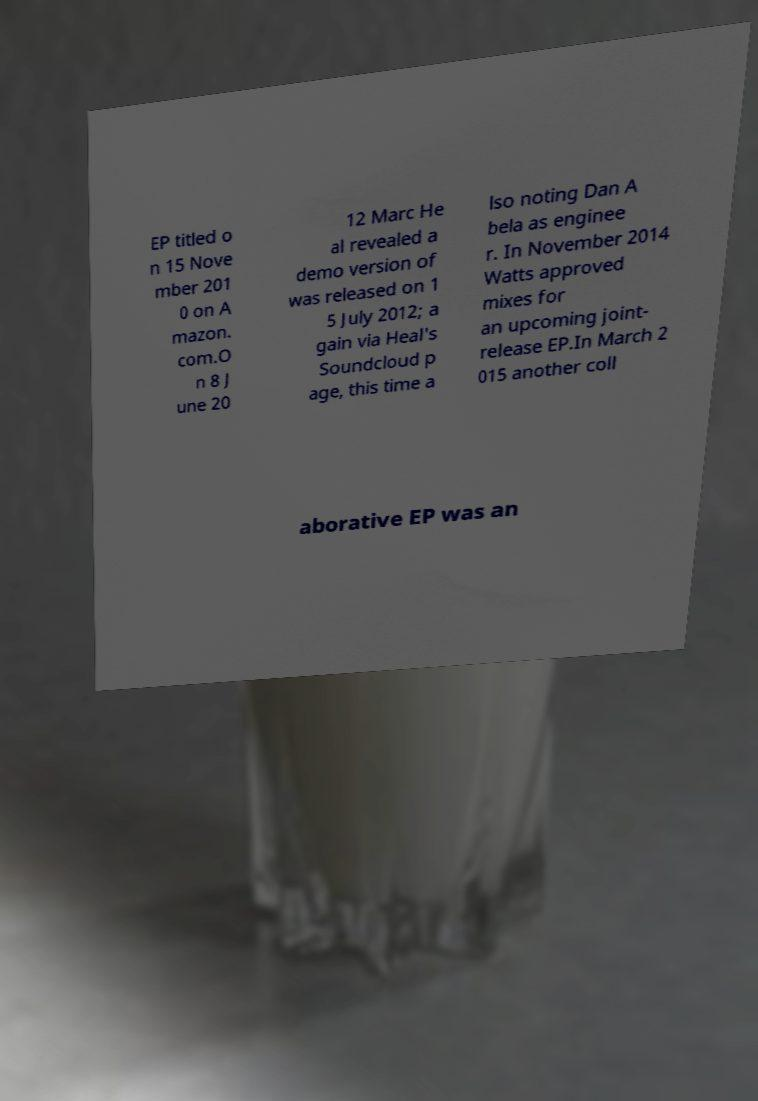Please identify and transcribe the text found in this image. EP titled o n 15 Nove mber 201 0 on A mazon. com.O n 8 J une 20 12 Marc He al revealed a demo version of was released on 1 5 July 2012; a gain via Heal's Soundcloud p age, this time a lso noting Dan A bela as enginee r. In November 2014 Watts approved mixes for an upcoming joint- release EP.In March 2 015 another coll aborative EP was an 